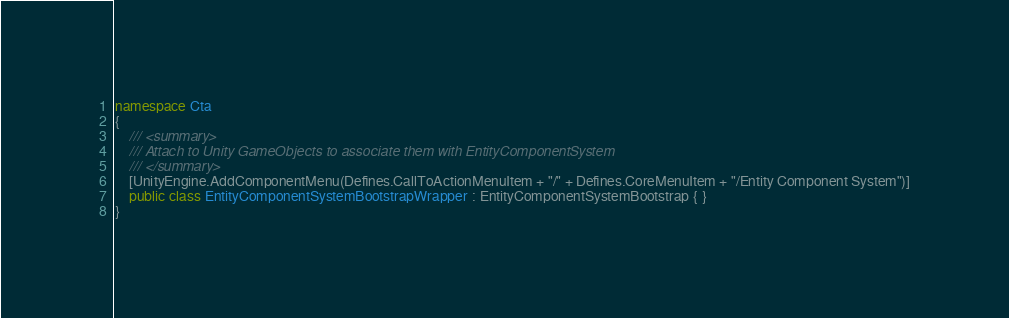<code> <loc_0><loc_0><loc_500><loc_500><_C#_>
namespace Cta
{
	/// <summary>
	/// Attach to Unity GameObjects to associate them with EntityComponentSystem
	/// </summary>
	[UnityEngine.AddComponentMenu(Defines.CallToActionMenuItem + "/" + Defines.CoreMenuItem + "/Entity Component System")]
	public class EntityComponentSystemBootstrapWrapper : EntityComponentSystemBootstrap { }
}
</code> 